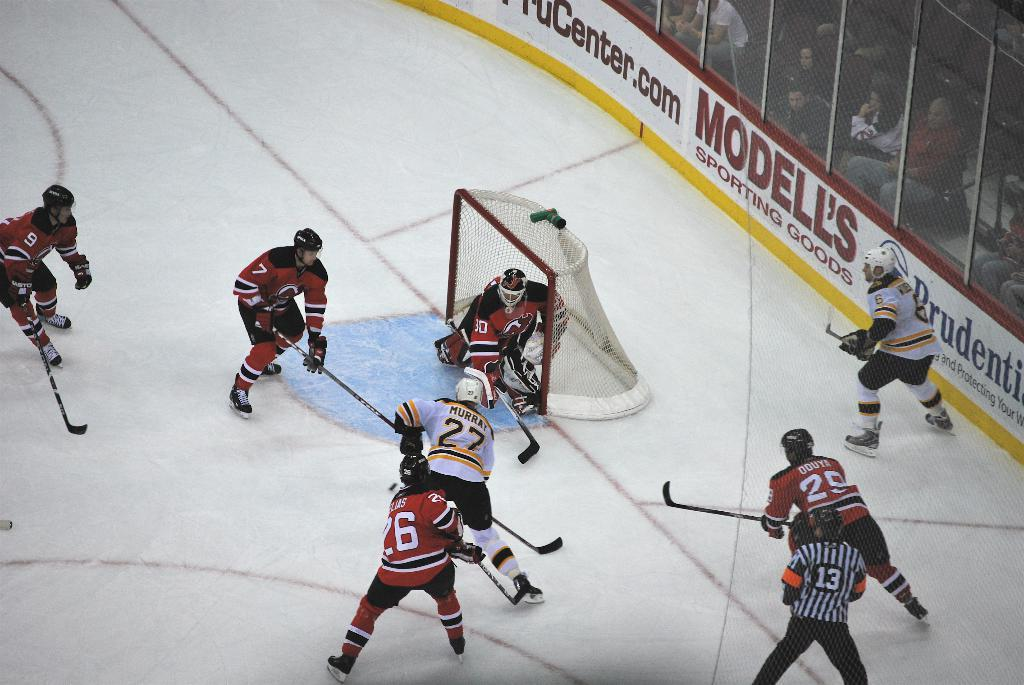<image>
Give a short and clear explanation of the subsequent image. Player number 27 in white gets ready to shoot a hockey puck while player 30 in red looks to make a save. 